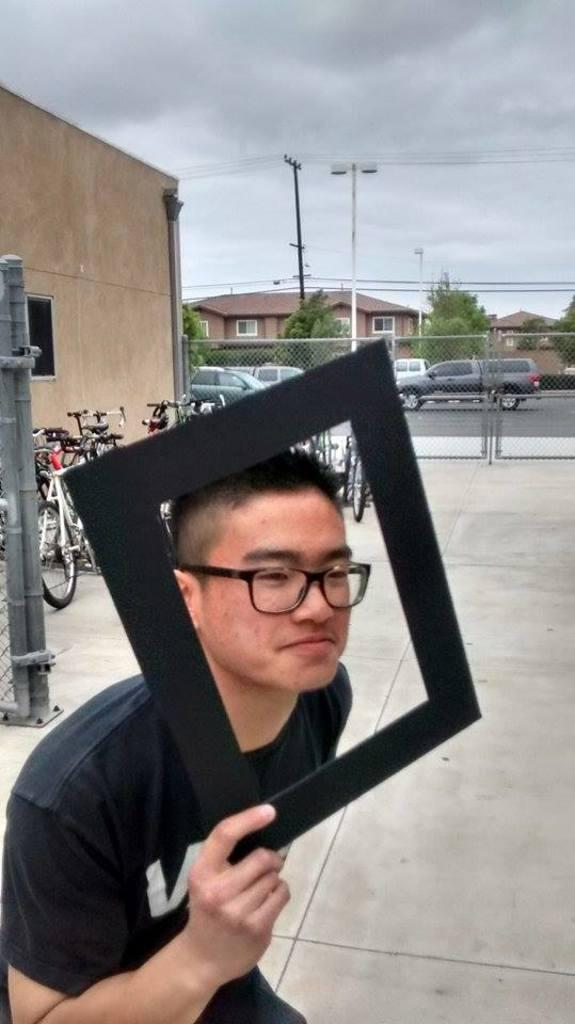What is the man in the image holding? The man is holding a frame in the image. What can be seen at the bottom of the image? There is a road at the bottom of the image. What is visible in the background of the image? There are cycles and a gate in the background of the image. What is visible in the sky at the top of the image? There are clouds in the sky at the top of the image. Can you see any cans of soda on the island in the image? There is no island present in the image, so it is not possible to see any cans of soda on an island. 